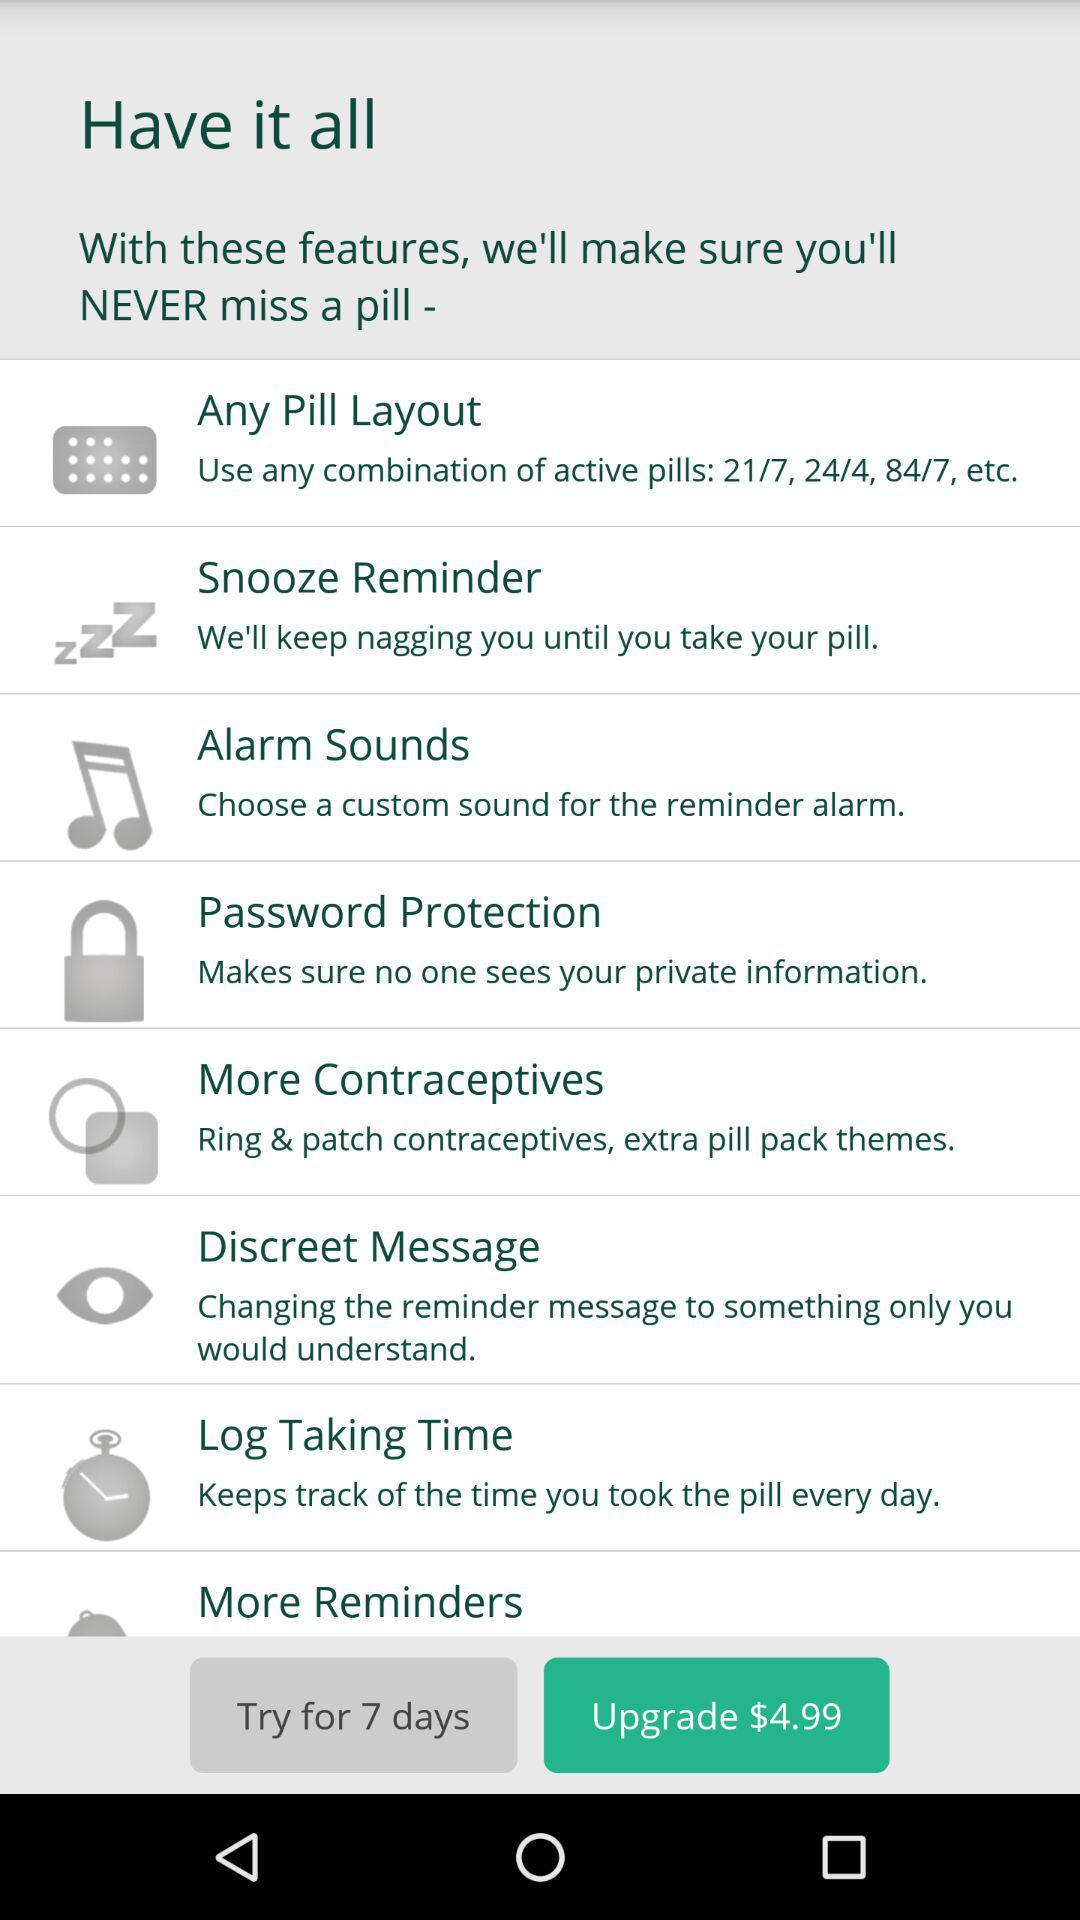What is the date of taking the pill?
When the provided information is insufficient, respond with <no answer>. <no answer> 